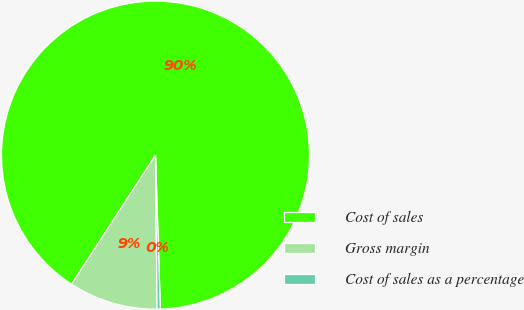Convert chart to OTSL. <chart><loc_0><loc_0><loc_500><loc_500><pie_chart><fcel>Cost of sales<fcel>Gross margin<fcel>Cost of sales as a percentage<nl><fcel>90.33%<fcel>9.34%<fcel>0.34%<nl></chart> 